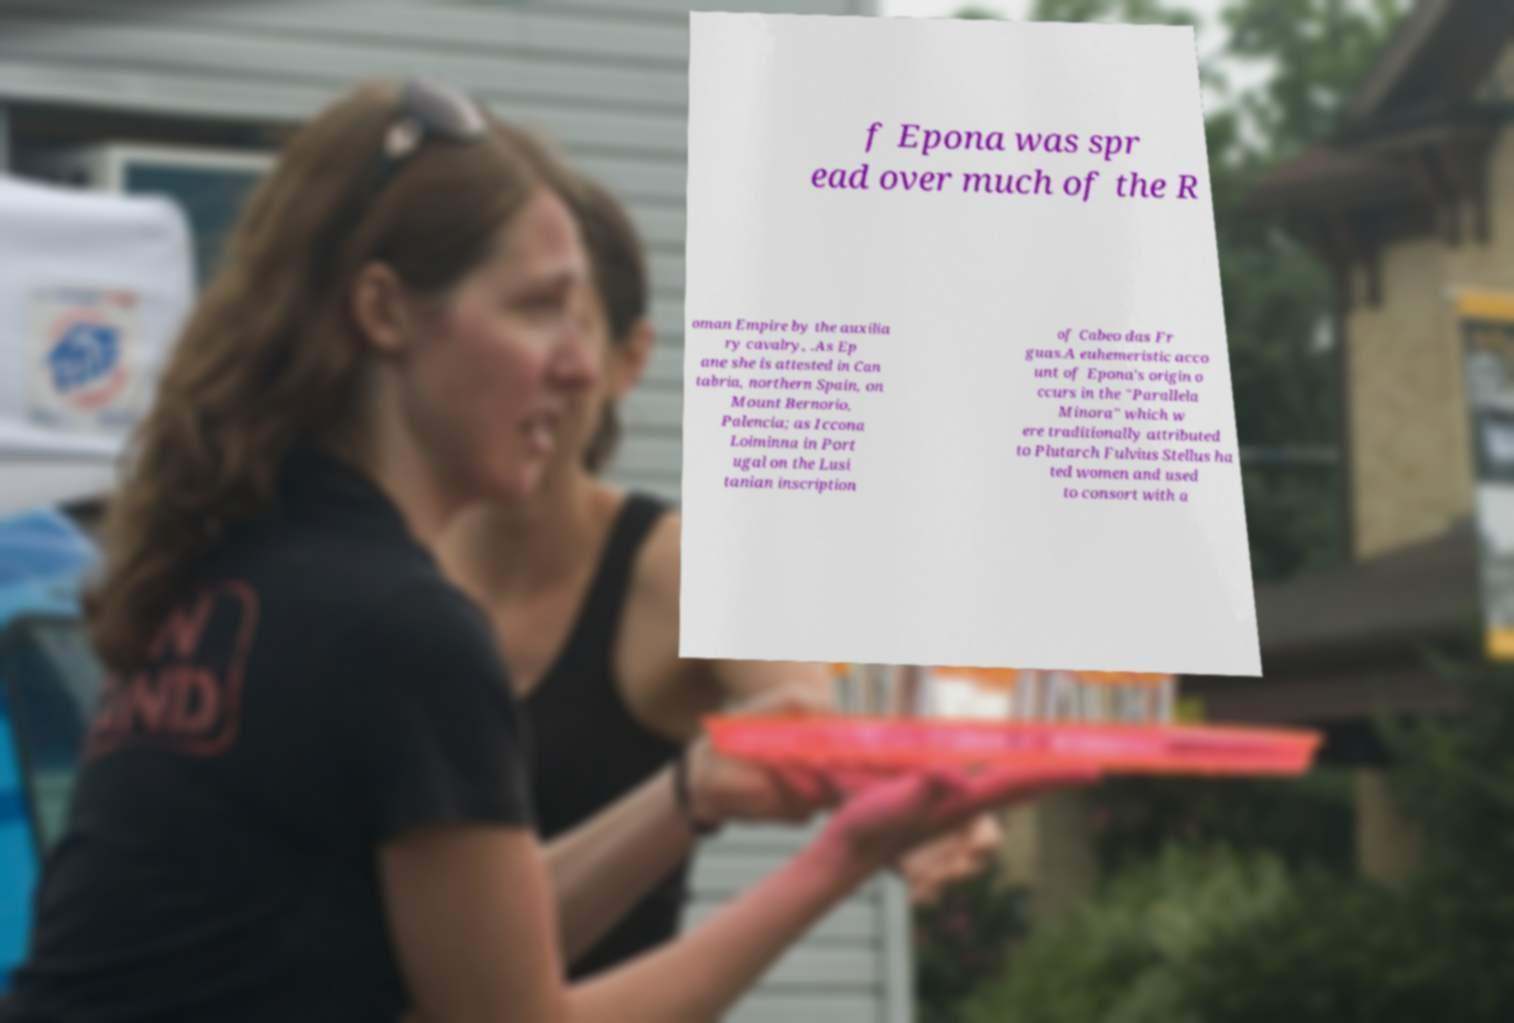Please identify and transcribe the text found in this image. f Epona was spr ead over much of the R oman Empire by the auxilia ry cavalry, .As Ep ane she is attested in Can tabria, northern Spain, on Mount Bernorio, Palencia; as Iccona Loiminna in Port ugal on the Lusi tanian inscription of Cabeo das Fr guas.A euhemeristic acco unt of Epona's origin o ccurs in the "Parallela Minora" which w ere traditionally attributed to Plutarch Fulvius Stellus ha ted women and used to consort with a 